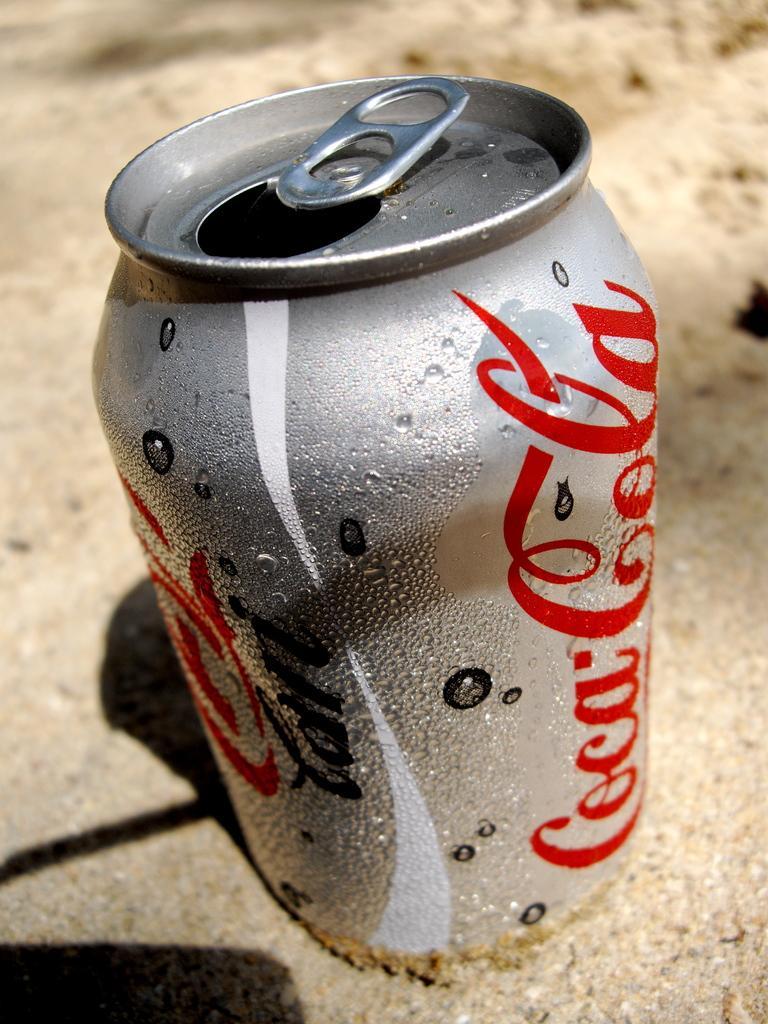Provide a one-sentence caption for the provided image. A can of diet Coca-cola is sitting on the sand. 